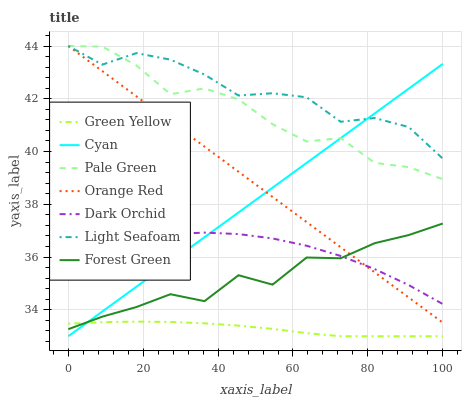Does Dark Orchid have the minimum area under the curve?
Answer yes or no. No. Does Dark Orchid have the maximum area under the curve?
Answer yes or no. No. Is Dark Orchid the smoothest?
Answer yes or no. No. Is Dark Orchid the roughest?
Answer yes or no. No. Does Dark Orchid have the lowest value?
Answer yes or no. No. Does Dark Orchid have the highest value?
Answer yes or no. No. Is Dark Orchid less than Pale Green?
Answer yes or no. Yes. Is Dark Orchid greater than Green Yellow?
Answer yes or no. Yes. Does Dark Orchid intersect Pale Green?
Answer yes or no. No. 